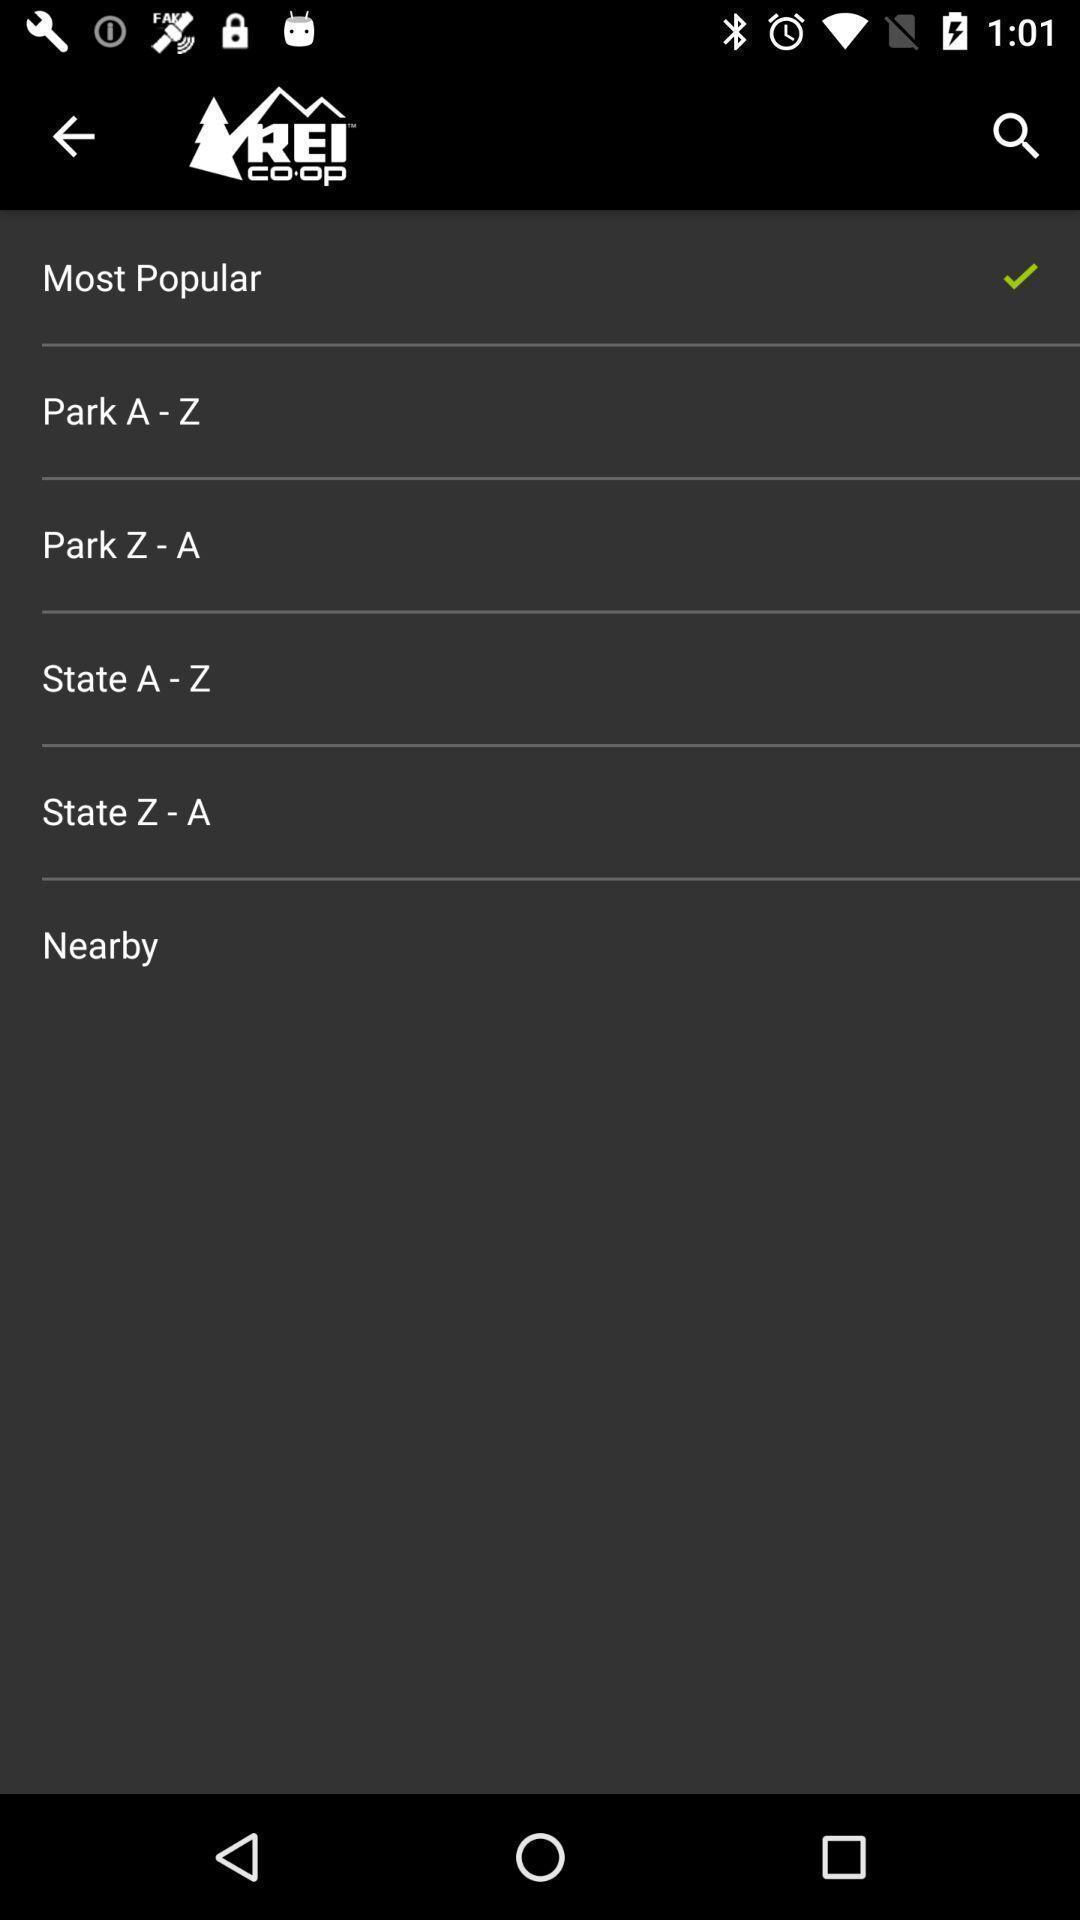Describe the key features of this screenshot. Screen shows about a national park guide. 